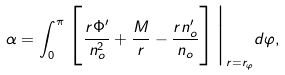<formula> <loc_0><loc_0><loc_500><loc_500>\alpha = \int _ { 0 } ^ { \pi } \Big [ \frac { r \Phi ^ { \prime } } { n _ { o } ^ { 2 } } + \frac { M } { r } - \frac { r n _ { o } ^ { \prime } } { n _ { o } } \Big ] \Big | _ { r = r _ { \varphi } } d \varphi ,</formula> 